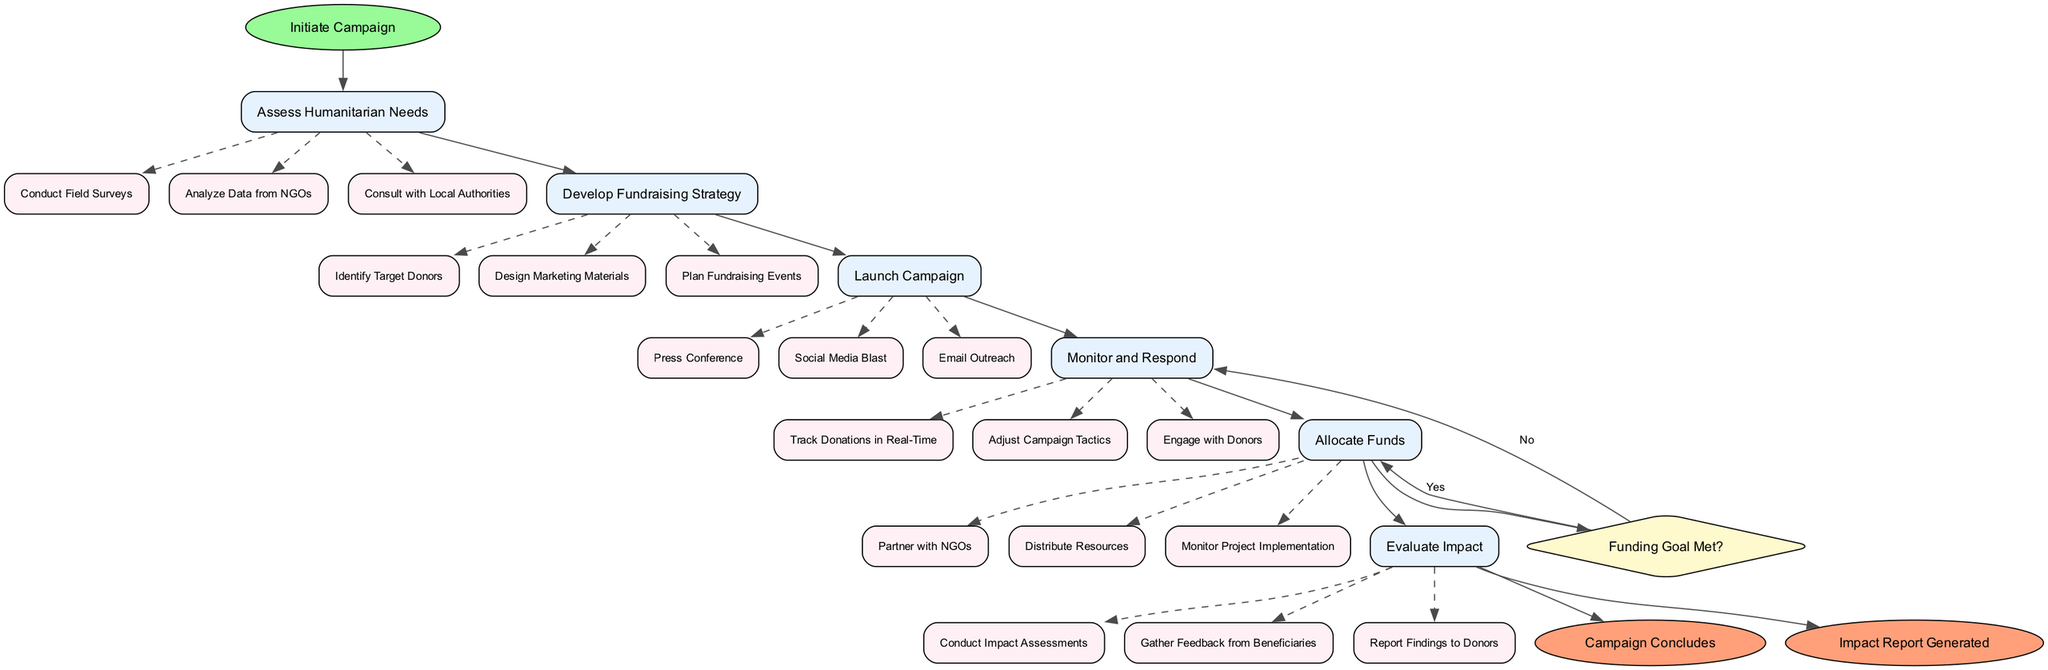What is the starting point of the campaign? The starting point is labeled as "Initiate Campaign" in the diagram.
Answer: Initiate Campaign How many actions are there in the diagram? There are six actions listed in the diagram, each representing a different step in the workflow.
Answer: 6 What happens if the funding goal is met? If the funding goal is met, the next step in the workflow is to "Allocate Funds" as indicated by the true path from the decision point.
Answer: Allocate Funds What is the first sub-action under "Assess Humanitarian Needs"? The first sub-action under "Assess Humanitarian Needs" is "Conduct Field Surveys." This can be deduced from the listed sub-actions under that action.
Answer: Conduct Field Surveys Which action directly leads to the "Evaluate Impact" step? The action preceding "Evaluate Impact" is "Allocate Funds," indicated by the arrows in the diagram connecting actions sequentially.
Answer: Allocate Funds What is the endpoint of the workflow? The diagram contains two endpoints, and one of them is labeled as "Campaign Concludes." This is derived from the section of the diagram designated for endpoints.
Answer: Campaign Concludes What are the three sub-actions listed under "Develop Fundraising Strategy"? The three sub-actions under "Develop Fundraising Strategy" are "Identify Target Donors," "Design Marketing Materials," and "Plan Fundraising Events," as specified in the workflow.
Answer: Identify Target Donors, Design Marketing Materials, Plan Fundraising Events If the funding goal is not met, what is the next action? If the funding goal is not met, the next action is to "Adjust Campaign Tactics," which is the false path resulting from the decision point.
Answer: Adjust Campaign Tactics How many decision points are there in the diagram? There is one decision point in the diagram, which is "Funding Goal Met?" This is clearly marked in the flow of the actions leading to it.
Answer: 1 